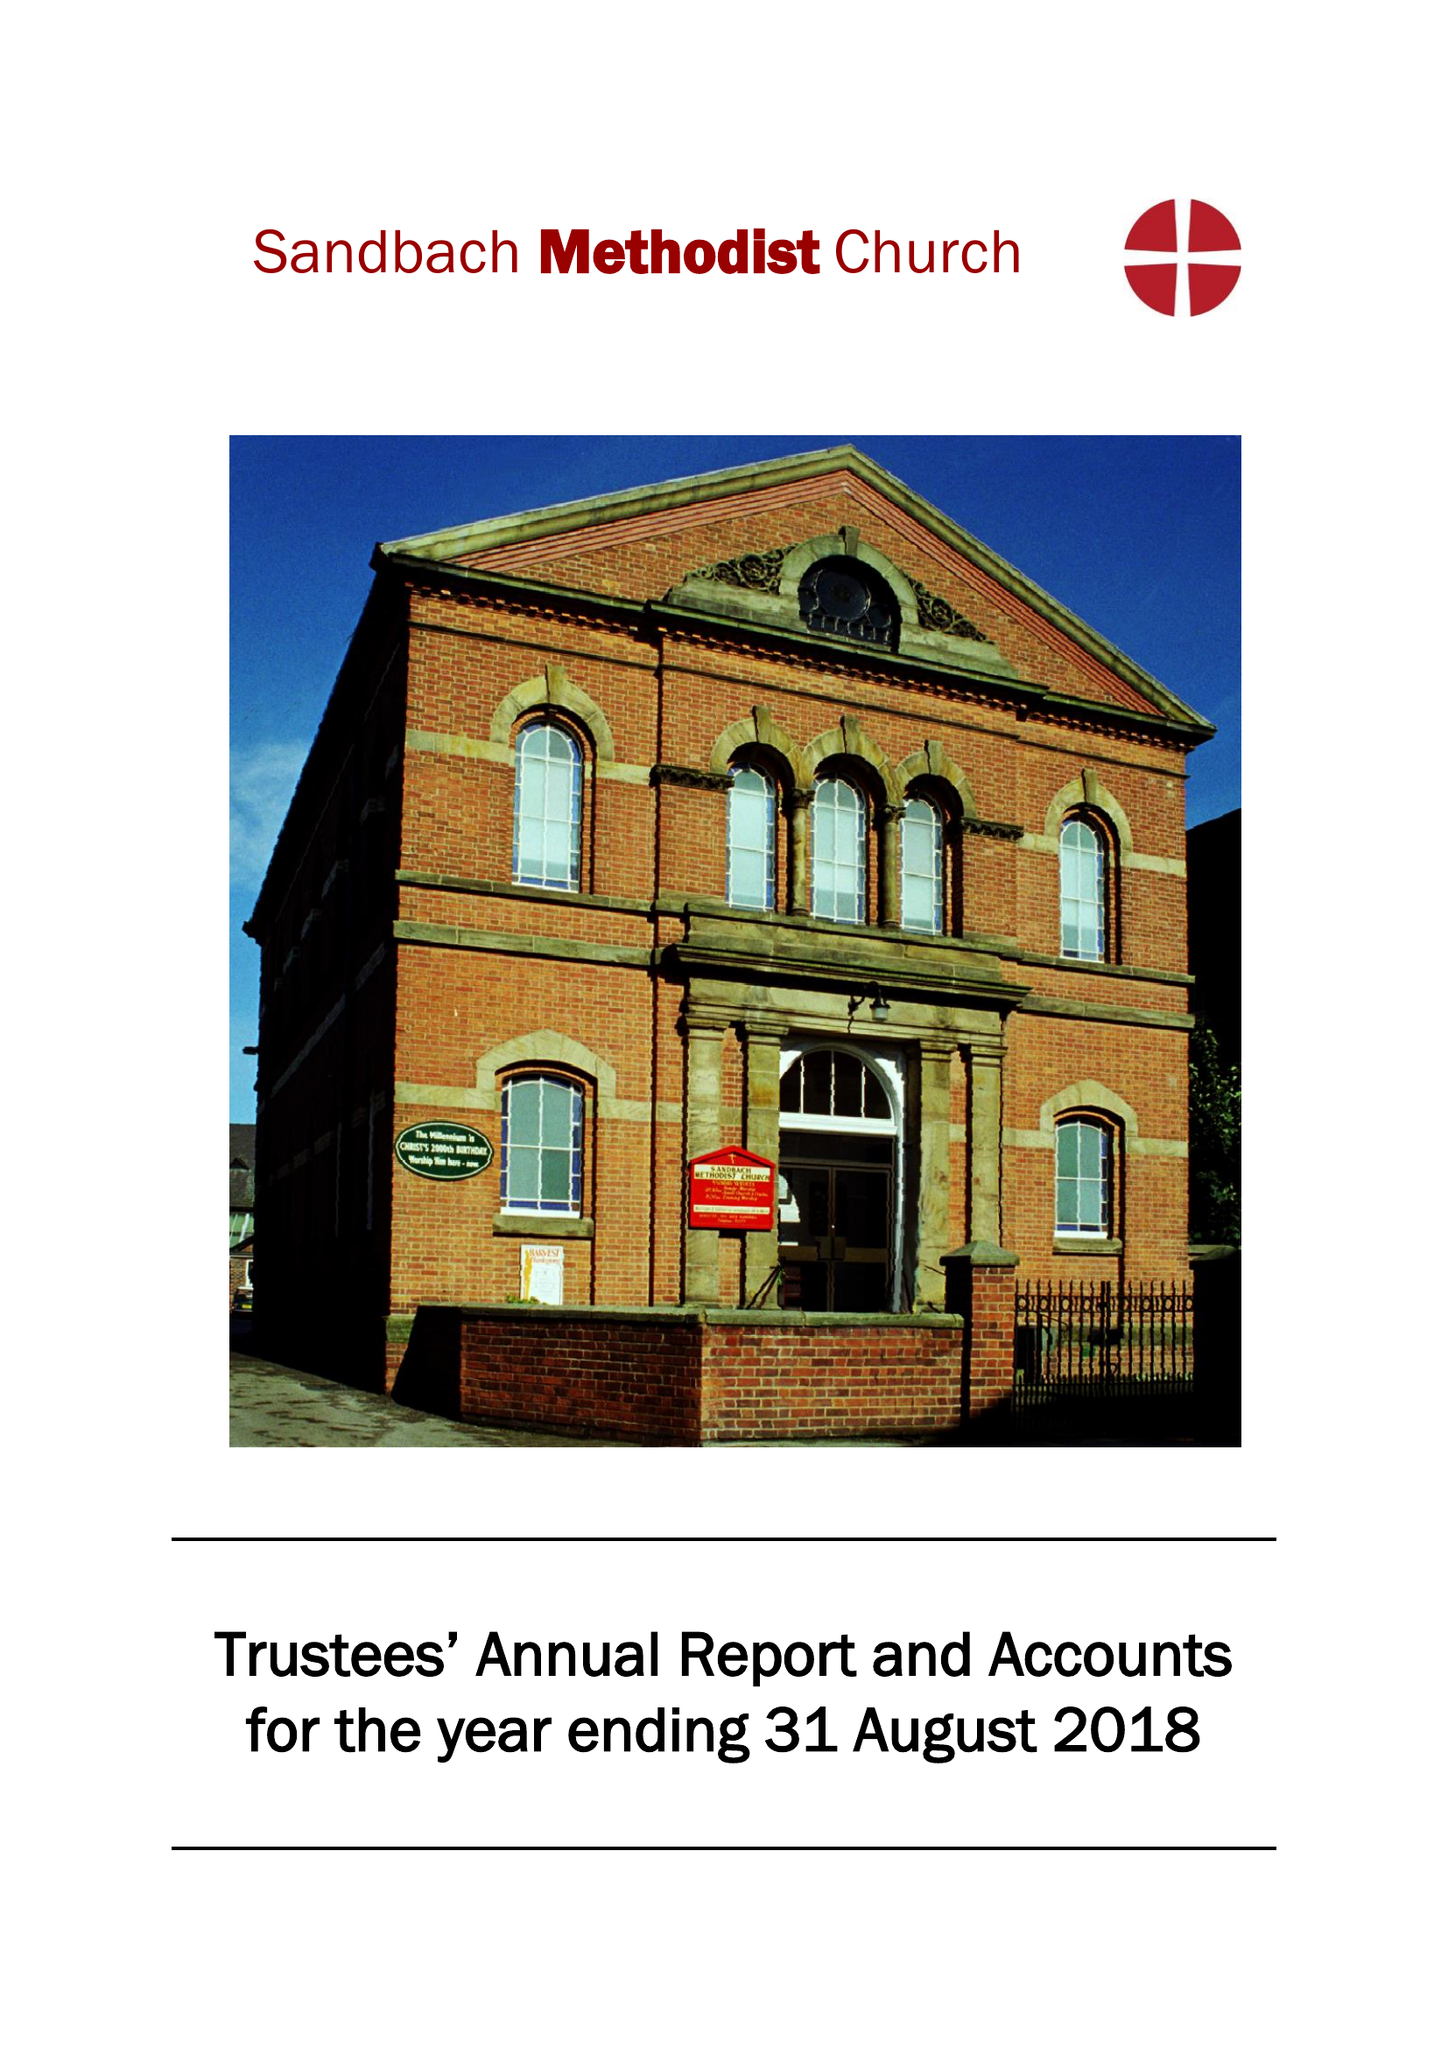What is the value for the charity_name?
Answer the question using a single word or phrase. Sandbach Methodist Church 